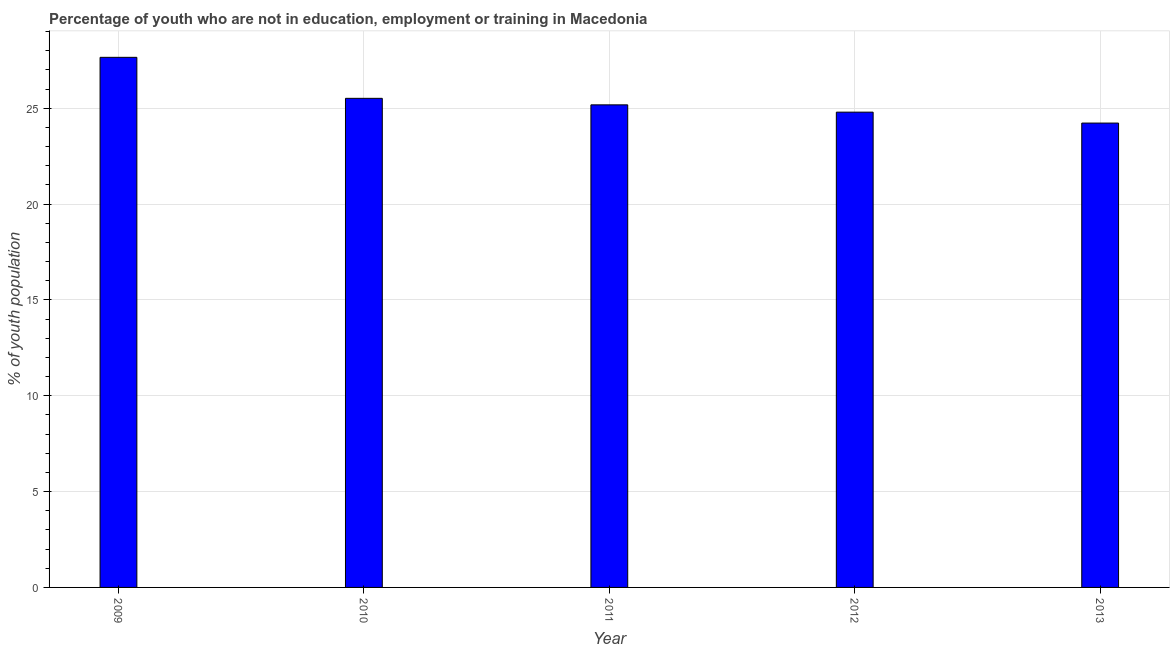Does the graph contain any zero values?
Your response must be concise. No. Does the graph contain grids?
Provide a succinct answer. Yes. What is the title of the graph?
Offer a terse response. Percentage of youth who are not in education, employment or training in Macedonia. What is the label or title of the X-axis?
Give a very brief answer. Year. What is the label or title of the Y-axis?
Offer a terse response. % of youth population. What is the unemployed youth population in 2010?
Ensure brevity in your answer.  25.52. Across all years, what is the maximum unemployed youth population?
Provide a succinct answer. 27.66. Across all years, what is the minimum unemployed youth population?
Your response must be concise. 24.23. What is the sum of the unemployed youth population?
Make the answer very short. 127.39. What is the difference between the unemployed youth population in 2011 and 2012?
Provide a short and direct response. 0.38. What is the average unemployed youth population per year?
Give a very brief answer. 25.48. What is the median unemployed youth population?
Keep it short and to the point. 25.18. Do a majority of the years between 2011 and 2010 (inclusive) have unemployed youth population greater than 14 %?
Make the answer very short. No. What is the ratio of the unemployed youth population in 2009 to that in 2013?
Make the answer very short. 1.14. Is the unemployed youth population in 2009 less than that in 2012?
Offer a very short reply. No. What is the difference between the highest and the second highest unemployed youth population?
Ensure brevity in your answer.  2.14. Is the sum of the unemployed youth population in 2009 and 2010 greater than the maximum unemployed youth population across all years?
Provide a short and direct response. Yes. What is the difference between the highest and the lowest unemployed youth population?
Give a very brief answer. 3.43. In how many years, is the unemployed youth population greater than the average unemployed youth population taken over all years?
Ensure brevity in your answer.  2. How many bars are there?
Ensure brevity in your answer.  5. Are the values on the major ticks of Y-axis written in scientific E-notation?
Offer a terse response. No. What is the % of youth population in 2009?
Your answer should be compact. 27.66. What is the % of youth population of 2010?
Give a very brief answer. 25.52. What is the % of youth population of 2011?
Make the answer very short. 25.18. What is the % of youth population in 2012?
Give a very brief answer. 24.8. What is the % of youth population in 2013?
Provide a succinct answer. 24.23. What is the difference between the % of youth population in 2009 and 2010?
Make the answer very short. 2.14. What is the difference between the % of youth population in 2009 and 2011?
Ensure brevity in your answer.  2.48. What is the difference between the % of youth population in 2009 and 2012?
Offer a terse response. 2.86. What is the difference between the % of youth population in 2009 and 2013?
Your response must be concise. 3.43. What is the difference between the % of youth population in 2010 and 2011?
Keep it short and to the point. 0.34. What is the difference between the % of youth population in 2010 and 2012?
Offer a terse response. 0.72. What is the difference between the % of youth population in 2010 and 2013?
Keep it short and to the point. 1.29. What is the difference between the % of youth population in 2011 and 2012?
Your answer should be compact. 0.38. What is the difference between the % of youth population in 2012 and 2013?
Provide a succinct answer. 0.57. What is the ratio of the % of youth population in 2009 to that in 2010?
Give a very brief answer. 1.08. What is the ratio of the % of youth population in 2009 to that in 2011?
Your answer should be compact. 1.1. What is the ratio of the % of youth population in 2009 to that in 2012?
Give a very brief answer. 1.11. What is the ratio of the % of youth population in 2009 to that in 2013?
Ensure brevity in your answer.  1.14. What is the ratio of the % of youth population in 2010 to that in 2011?
Keep it short and to the point. 1.01. What is the ratio of the % of youth population in 2010 to that in 2012?
Ensure brevity in your answer.  1.03. What is the ratio of the % of youth population in 2010 to that in 2013?
Provide a succinct answer. 1.05. What is the ratio of the % of youth population in 2011 to that in 2013?
Your answer should be very brief. 1.04. What is the ratio of the % of youth population in 2012 to that in 2013?
Keep it short and to the point. 1.02. 